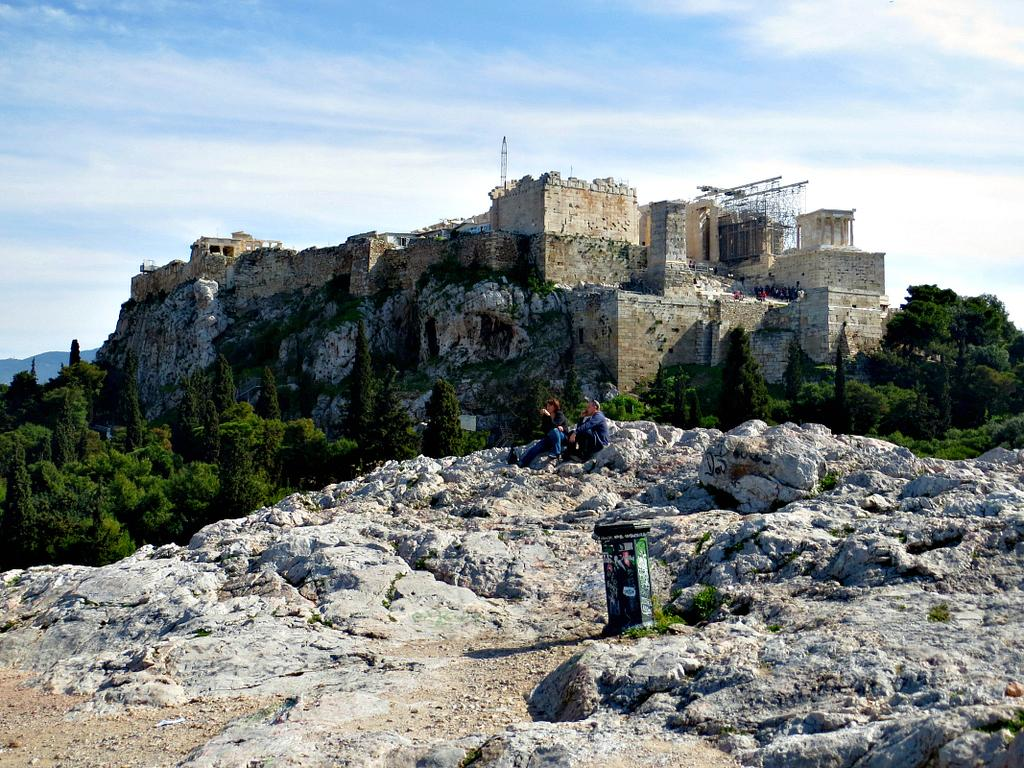What type of structure is visible in the image? There is a fort in the image. What can be seen in front of the fort? There are trees in front of the fort. Are there any people present in the image? Yes, there are two people sitting on rocks in the image. What type of porter is serving drinks to the minister in the image? There is no porter or minister present in the image; it only features a fort, trees, and two people sitting on rocks. 